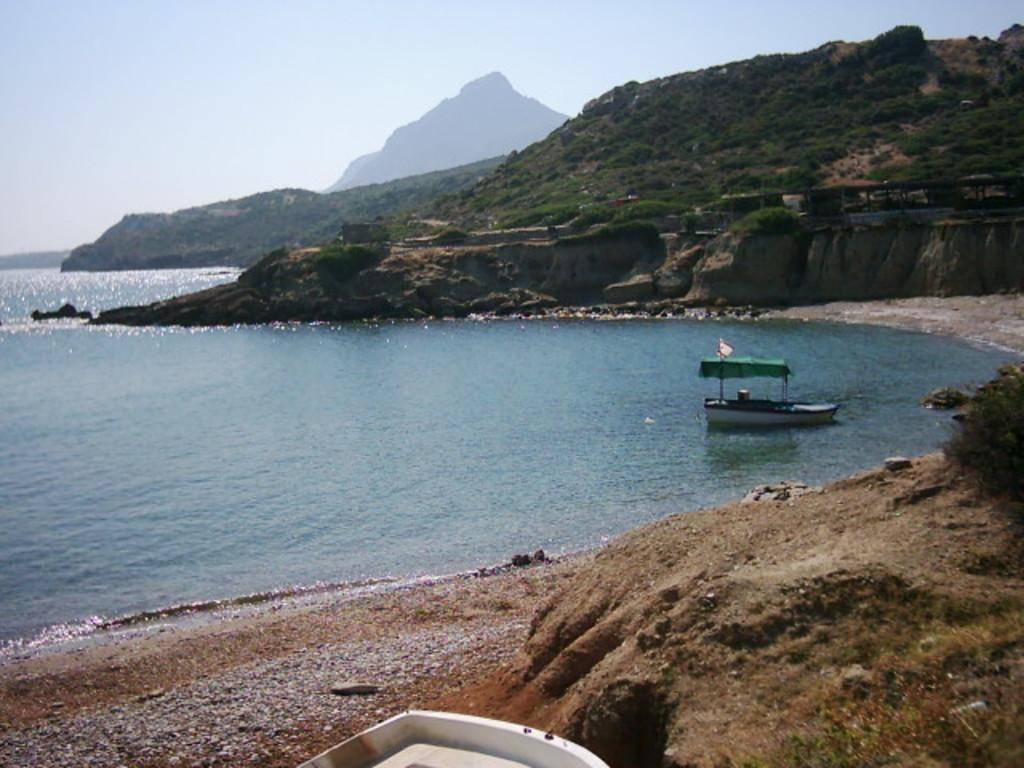What is the main subject in the center of the image? There is water in the center of the image. What can be seen on the right side of the image? There are mountains and a boat on the water on the right side of the image. What type of sound can be heard coming from the cactus in the image? There is no cactus present in the image, so it's not possible to determine what, if any, sound might be heard. 